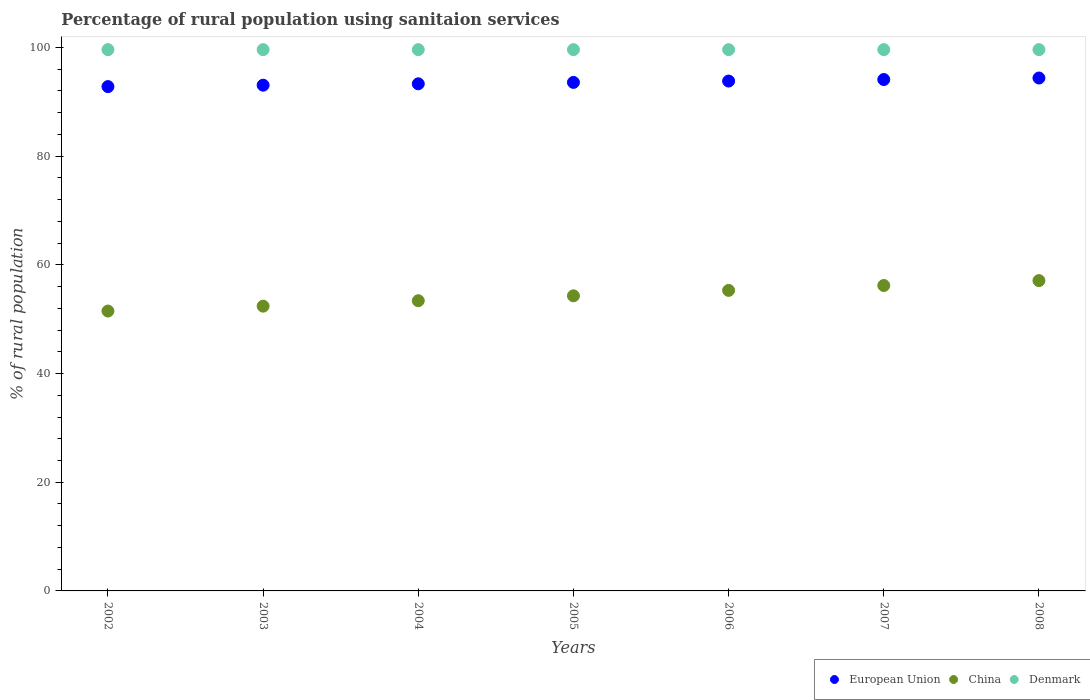How many different coloured dotlines are there?
Give a very brief answer. 3. What is the percentage of rural population using sanitaion services in European Union in 2006?
Your answer should be compact. 93.82. Across all years, what is the maximum percentage of rural population using sanitaion services in Denmark?
Ensure brevity in your answer.  99.6. Across all years, what is the minimum percentage of rural population using sanitaion services in Denmark?
Keep it short and to the point. 99.6. In which year was the percentage of rural population using sanitaion services in China minimum?
Your answer should be compact. 2002. What is the total percentage of rural population using sanitaion services in European Union in the graph?
Offer a terse response. 655.05. What is the difference between the percentage of rural population using sanitaion services in China in 2003 and that in 2008?
Provide a succinct answer. -4.7. What is the difference between the percentage of rural population using sanitaion services in European Union in 2002 and the percentage of rural population using sanitaion services in Denmark in 2005?
Your response must be concise. -6.8. What is the average percentage of rural population using sanitaion services in European Union per year?
Your answer should be compact. 93.58. In the year 2004, what is the difference between the percentage of rural population using sanitaion services in China and percentage of rural population using sanitaion services in Denmark?
Your response must be concise. -46.2. Is the difference between the percentage of rural population using sanitaion services in China in 2005 and 2006 greater than the difference between the percentage of rural population using sanitaion services in Denmark in 2005 and 2006?
Offer a terse response. No. What is the difference between the highest and the second highest percentage of rural population using sanitaion services in China?
Ensure brevity in your answer.  0.9. What is the difference between the highest and the lowest percentage of rural population using sanitaion services in European Union?
Your answer should be very brief. 1.58. In how many years, is the percentage of rural population using sanitaion services in Denmark greater than the average percentage of rural population using sanitaion services in Denmark taken over all years?
Your answer should be very brief. 0. Is the percentage of rural population using sanitaion services in European Union strictly less than the percentage of rural population using sanitaion services in China over the years?
Keep it short and to the point. No. How many dotlines are there?
Provide a succinct answer. 3. How many years are there in the graph?
Ensure brevity in your answer.  7. What is the difference between two consecutive major ticks on the Y-axis?
Give a very brief answer. 20. Are the values on the major ticks of Y-axis written in scientific E-notation?
Offer a terse response. No. Does the graph contain any zero values?
Offer a very short reply. No. What is the title of the graph?
Provide a succinct answer. Percentage of rural population using sanitaion services. What is the label or title of the X-axis?
Provide a short and direct response. Years. What is the label or title of the Y-axis?
Your answer should be very brief. % of rural population. What is the % of rural population in European Union in 2002?
Your response must be concise. 92.8. What is the % of rural population in China in 2002?
Offer a very short reply. 51.5. What is the % of rural population of Denmark in 2002?
Your answer should be compact. 99.6. What is the % of rural population in European Union in 2003?
Your answer should be compact. 93.06. What is the % of rural population of China in 2003?
Give a very brief answer. 52.4. What is the % of rural population of Denmark in 2003?
Ensure brevity in your answer.  99.6. What is the % of rural population in European Union in 2004?
Offer a very short reply. 93.31. What is the % of rural population of China in 2004?
Your answer should be compact. 53.4. What is the % of rural population of Denmark in 2004?
Keep it short and to the point. 99.6. What is the % of rural population in European Union in 2005?
Keep it short and to the point. 93.57. What is the % of rural population in China in 2005?
Offer a terse response. 54.3. What is the % of rural population in Denmark in 2005?
Ensure brevity in your answer.  99.6. What is the % of rural population in European Union in 2006?
Give a very brief answer. 93.82. What is the % of rural population of China in 2006?
Make the answer very short. 55.3. What is the % of rural population of Denmark in 2006?
Ensure brevity in your answer.  99.6. What is the % of rural population in European Union in 2007?
Make the answer very short. 94.1. What is the % of rural population of China in 2007?
Your response must be concise. 56.2. What is the % of rural population of Denmark in 2007?
Make the answer very short. 99.6. What is the % of rural population of European Union in 2008?
Ensure brevity in your answer.  94.38. What is the % of rural population in China in 2008?
Keep it short and to the point. 57.1. What is the % of rural population of Denmark in 2008?
Offer a very short reply. 99.6. Across all years, what is the maximum % of rural population in European Union?
Provide a succinct answer. 94.38. Across all years, what is the maximum % of rural population of China?
Your response must be concise. 57.1. Across all years, what is the maximum % of rural population of Denmark?
Offer a very short reply. 99.6. Across all years, what is the minimum % of rural population of European Union?
Make the answer very short. 92.8. Across all years, what is the minimum % of rural population in China?
Offer a very short reply. 51.5. Across all years, what is the minimum % of rural population of Denmark?
Give a very brief answer. 99.6. What is the total % of rural population of European Union in the graph?
Provide a succinct answer. 655.05. What is the total % of rural population in China in the graph?
Provide a short and direct response. 380.2. What is the total % of rural population in Denmark in the graph?
Your answer should be compact. 697.2. What is the difference between the % of rural population of European Union in 2002 and that in 2003?
Keep it short and to the point. -0.26. What is the difference between the % of rural population in Denmark in 2002 and that in 2003?
Provide a short and direct response. 0. What is the difference between the % of rural population in European Union in 2002 and that in 2004?
Provide a short and direct response. -0.51. What is the difference between the % of rural population of China in 2002 and that in 2004?
Offer a very short reply. -1.9. What is the difference between the % of rural population of European Union in 2002 and that in 2005?
Your answer should be very brief. -0.77. What is the difference between the % of rural population of China in 2002 and that in 2005?
Make the answer very short. -2.8. What is the difference between the % of rural population of European Union in 2002 and that in 2006?
Provide a short and direct response. -1.02. What is the difference between the % of rural population of European Union in 2002 and that in 2007?
Your response must be concise. -1.3. What is the difference between the % of rural population in China in 2002 and that in 2007?
Ensure brevity in your answer.  -4.7. What is the difference between the % of rural population in Denmark in 2002 and that in 2007?
Keep it short and to the point. 0. What is the difference between the % of rural population in European Union in 2002 and that in 2008?
Your answer should be very brief. -1.58. What is the difference between the % of rural population in China in 2002 and that in 2008?
Offer a terse response. -5.6. What is the difference between the % of rural population of European Union in 2003 and that in 2004?
Your answer should be very brief. -0.25. What is the difference between the % of rural population in China in 2003 and that in 2004?
Give a very brief answer. -1. What is the difference between the % of rural population of Denmark in 2003 and that in 2004?
Provide a short and direct response. 0. What is the difference between the % of rural population in European Union in 2003 and that in 2005?
Give a very brief answer. -0.51. What is the difference between the % of rural population in Denmark in 2003 and that in 2005?
Provide a succinct answer. 0. What is the difference between the % of rural population in European Union in 2003 and that in 2006?
Make the answer very short. -0.76. What is the difference between the % of rural population of China in 2003 and that in 2006?
Your answer should be compact. -2.9. What is the difference between the % of rural population of Denmark in 2003 and that in 2006?
Your answer should be compact. 0. What is the difference between the % of rural population in European Union in 2003 and that in 2007?
Offer a very short reply. -1.04. What is the difference between the % of rural population of China in 2003 and that in 2007?
Give a very brief answer. -3.8. What is the difference between the % of rural population of European Union in 2003 and that in 2008?
Your response must be concise. -1.32. What is the difference between the % of rural population of European Union in 2004 and that in 2005?
Make the answer very short. -0.26. What is the difference between the % of rural population of China in 2004 and that in 2005?
Keep it short and to the point. -0.9. What is the difference between the % of rural population in European Union in 2004 and that in 2006?
Make the answer very short. -0.51. What is the difference between the % of rural population in European Union in 2004 and that in 2007?
Provide a short and direct response. -0.79. What is the difference between the % of rural population of China in 2004 and that in 2007?
Offer a very short reply. -2.8. What is the difference between the % of rural population of European Union in 2004 and that in 2008?
Make the answer very short. -1.07. What is the difference between the % of rural population of European Union in 2005 and that in 2006?
Your response must be concise. -0.25. What is the difference between the % of rural population of China in 2005 and that in 2006?
Offer a very short reply. -1. What is the difference between the % of rural population of European Union in 2005 and that in 2007?
Make the answer very short. -0.53. What is the difference between the % of rural population of China in 2005 and that in 2007?
Keep it short and to the point. -1.9. What is the difference between the % of rural population in European Union in 2005 and that in 2008?
Offer a very short reply. -0.81. What is the difference between the % of rural population of China in 2005 and that in 2008?
Provide a short and direct response. -2.8. What is the difference between the % of rural population of Denmark in 2005 and that in 2008?
Your response must be concise. 0. What is the difference between the % of rural population in European Union in 2006 and that in 2007?
Make the answer very short. -0.28. What is the difference between the % of rural population in China in 2006 and that in 2007?
Provide a succinct answer. -0.9. What is the difference between the % of rural population of European Union in 2006 and that in 2008?
Offer a very short reply. -0.56. What is the difference between the % of rural population of European Union in 2007 and that in 2008?
Give a very brief answer. -0.28. What is the difference between the % of rural population of China in 2007 and that in 2008?
Your answer should be very brief. -0.9. What is the difference between the % of rural population in Denmark in 2007 and that in 2008?
Your answer should be very brief. 0. What is the difference between the % of rural population of European Union in 2002 and the % of rural population of China in 2003?
Make the answer very short. 40.4. What is the difference between the % of rural population of European Union in 2002 and the % of rural population of Denmark in 2003?
Offer a terse response. -6.8. What is the difference between the % of rural population of China in 2002 and the % of rural population of Denmark in 2003?
Keep it short and to the point. -48.1. What is the difference between the % of rural population in European Union in 2002 and the % of rural population in China in 2004?
Keep it short and to the point. 39.4. What is the difference between the % of rural population of European Union in 2002 and the % of rural population of Denmark in 2004?
Make the answer very short. -6.8. What is the difference between the % of rural population in China in 2002 and the % of rural population in Denmark in 2004?
Provide a short and direct response. -48.1. What is the difference between the % of rural population in European Union in 2002 and the % of rural population in China in 2005?
Give a very brief answer. 38.5. What is the difference between the % of rural population of European Union in 2002 and the % of rural population of Denmark in 2005?
Give a very brief answer. -6.8. What is the difference between the % of rural population of China in 2002 and the % of rural population of Denmark in 2005?
Your answer should be compact. -48.1. What is the difference between the % of rural population in European Union in 2002 and the % of rural population in China in 2006?
Your answer should be compact. 37.5. What is the difference between the % of rural population of European Union in 2002 and the % of rural population of Denmark in 2006?
Offer a very short reply. -6.8. What is the difference between the % of rural population of China in 2002 and the % of rural population of Denmark in 2006?
Your response must be concise. -48.1. What is the difference between the % of rural population of European Union in 2002 and the % of rural population of China in 2007?
Offer a terse response. 36.6. What is the difference between the % of rural population in European Union in 2002 and the % of rural population in Denmark in 2007?
Your response must be concise. -6.8. What is the difference between the % of rural population of China in 2002 and the % of rural population of Denmark in 2007?
Make the answer very short. -48.1. What is the difference between the % of rural population in European Union in 2002 and the % of rural population in China in 2008?
Give a very brief answer. 35.7. What is the difference between the % of rural population in European Union in 2002 and the % of rural population in Denmark in 2008?
Make the answer very short. -6.8. What is the difference between the % of rural population of China in 2002 and the % of rural population of Denmark in 2008?
Ensure brevity in your answer.  -48.1. What is the difference between the % of rural population of European Union in 2003 and the % of rural population of China in 2004?
Ensure brevity in your answer.  39.66. What is the difference between the % of rural population in European Union in 2003 and the % of rural population in Denmark in 2004?
Your response must be concise. -6.54. What is the difference between the % of rural population in China in 2003 and the % of rural population in Denmark in 2004?
Keep it short and to the point. -47.2. What is the difference between the % of rural population of European Union in 2003 and the % of rural population of China in 2005?
Ensure brevity in your answer.  38.76. What is the difference between the % of rural population in European Union in 2003 and the % of rural population in Denmark in 2005?
Ensure brevity in your answer.  -6.54. What is the difference between the % of rural population in China in 2003 and the % of rural population in Denmark in 2005?
Your answer should be compact. -47.2. What is the difference between the % of rural population in European Union in 2003 and the % of rural population in China in 2006?
Provide a short and direct response. 37.76. What is the difference between the % of rural population of European Union in 2003 and the % of rural population of Denmark in 2006?
Give a very brief answer. -6.54. What is the difference between the % of rural population in China in 2003 and the % of rural population in Denmark in 2006?
Offer a very short reply. -47.2. What is the difference between the % of rural population in European Union in 2003 and the % of rural population in China in 2007?
Make the answer very short. 36.86. What is the difference between the % of rural population in European Union in 2003 and the % of rural population in Denmark in 2007?
Your answer should be very brief. -6.54. What is the difference between the % of rural population of China in 2003 and the % of rural population of Denmark in 2007?
Ensure brevity in your answer.  -47.2. What is the difference between the % of rural population of European Union in 2003 and the % of rural population of China in 2008?
Provide a short and direct response. 35.96. What is the difference between the % of rural population of European Union in 2003 and the % of rural population of Denmark in 2008?
Provide a short and direct response. -6.54. What is the difference between the % of rural population of China in 2003 and the % of rural population of Denmark in 2008?
Keep it short and to the point. -47.2. What is the difference between the % of rural population in European Union in 2004 and the % of rural population in China in 2005?
Provide a succinct answer. 39.01. What is the difference between the % of rural population in European Union in 2004 and the % of rural population in Denmark in 2005?
Your response must be concise. -6.29. What is the difference between the % of rural population in China in 2004 and the % of rural population in Denmark in 2005?
Make the answer very short. -46.2. What is the difference between the % of rural population in European Union in 2004 and the % of rural population in China in 2006?
Your answer should be compact. 38.01. What is the difference between the % of rural population of European Union in 2004 and the % of rural population of Denmark in 2006?
Your answer should be very brief. -6.29. What is the difference between the % of rural population of China in 2004 and the % of rural population of Denmark in 2006?
Offer a very short reply. -46.2. What is the difference between the % of rural population of European Union in 2004 and the % of rural population of China in 2007?
Keep it short and to the point. 37.11. What is the difference between the % of rural population in European Union in 2004 and the % of rural population in Denmark in 2007?
Offer a very short reply. -6.29. What is the difference between the % of rural population in China in 2004 and the % of rural population in Denmark in 2007?
Your answer should be compact. -46.2. What is the difference between the % of rural population in European Union in 2004 and the % of rural population in China in 2008?
Offer a terse response. 36.21. What is the difference between the % of rural population of European Union in 2004 and the % of rural population of Denmark in 2008?
Ensure brevity in your answer.  -6.29. What is the difference between the % of rural population in China in 2004 and the % of rural population in Denmark in 2008?
Your answer should be very brief. -46.2. What is the difference between the % of rural population of European Union in 2005 and the % of rural population of China in 2006?
Keep it short and to the point. 38.27. What is the difference between the % of rural population in European Union in 2005 and the % of rural population in Denmark in 2006?
Provide a short and direct response. -6.03. What is the difference between the % of rural population in China in 2005 and the % of rural population in Denmark in 2006?
Your answer should be compact. -45.3. What is the difference between the % of rural population in European Union in 2005 and the % of rural population in China in 2007?
Ensure brevity in your answer.  37.37. What is the difference between the % of rural population in European Union in 2005 and the % of rural population in Denmark in 2007?
Make the answer very short. -6.03. What is the difference between the % of rural population in China in 2005 and the % of rural population in Denmark in 2007?
Ensure brevity in your answer.  -45.3. What is the difference between the % of rural population of European Union in 2005 and the % of rural population of China in 2008?
Provide a short and direct response. 36.47. What is the difference between the % of rural population of European Union in 2005 and the % of rural population of Denmark in 2008?
Keep it short and to the point. -6.03. What is the difference between the % of rural population of China in 2005 and the % of rural population of Denmark in 2008?
Provide a succinct answer. -45.3. What is the difference between the % of rural population in European Union in 2006 and the % of rural population in China in 2007?
Provide a succinct answer. 37.62. What is the difference between the % of rural population of European Union in 2006 and the % of rural population of Denmark in 2007?
Your answer should be compact. -5.78. What is the difference between the % of rural population in China in 2006 and the % of rural population in Denmark in 2007?
Provide a short and direct response. -44.3. What is the difference between the % of rural population of European Union in 2006 and the % of rural population of China in 2008?
Your answer should be very brief. 36.72. What is the difference between the % of rural population in European Union in 2006 and the % of rural population in Denmark in 2008?
Give a very brief answer. -5.78. What is the difference between the % of rural population in China in 2006 and the % of rural population in Denmark in 2008?
Make the answer very short. -44.3. What is the difference between the % of rural population of European Union in 2007 and the % of rural population of China in 2008?
Provide a succinct answer. 37. What is the difference between the % of rural population in European Union in 2007 and the % of rural population in Denmark in 2008?
Keep it short and to the point. -5.5. What is the difference between the % of rural population of China in 2007 and the % of rural population of Denmark in 2008?
Provide a short and direct response. -43.4. What is the average % of rural population of European Union per year?
Give a very brief answer. 93.58. What is the average % of rural population in China per year?
Keep it short and to the point. 54.31. What is the average % of rural population in Denmark per year?
Offer a very short reply. 99.6. In the year 2002, what is the difference between the % of rural population in European Union and % of rural population in China?
Ensure brevity in your answer.  41.3. In the year 2002, what is the difference between the % of rural population in European Union and % of rural population in Denmark?
Provide a succinct answer. -6.8. In the year 2002, what is the difference between the % of rural population of China and % of rural population of Denmark?
Your answer should be compact. -48.1. In the year 2003, what is the difference between the % of rural population of European Union and % of rural population of China?
Ensure brevity in your answer.  40.66. In the year 2003, what is the difference between the % of rural population in European Union and % of rural population in Denmark?
Keep it short and to the point. -6.54. In the year 2003, what is the difference between the % of rural population in China and % of rural population in Denmark?
Your answer should be very brief. -47.2. In the year 2004, what is the difference between the % of rural population in European Union and % of rural population in China?
Keep it short and to the point. 39.91. In the year 2004, what is the difference between the % of rural population in European Union and % of rural population in Denmark?
Offer a very short reply. -6.29. In the year 2004, what is the difference between the % of rural population of China and % of rural population of Denmark?
Ensure brevity in your answer.  -46.2. In the year 2005, what is the difference between the % of rural population in European Union and % of rural population in China?
Your answer should be very brief. 39.27. In the year 2005, what is the difference between the % of rural population in European Union and % of rural population in Denmark?
Your answer should be compact. -6.03. In the year 2005, what is the difference between the % of rural population of China and % of rural population of Denmark?
Give a very brief answer. -45.3. In the year 2006, what is the difference between the % of rural population of European Union and % of rural population of China?
Give a very brief answer. 38.52. In the year 2006, what is the difference between the % of rural population of European Union and % of rural population of Denmark?
Your response must be concise. -5.78. In the year 2006, what is the difference between the % of rural population in China and % of rural population in Denmark?
Make the answer very short. -44.3. In the year 2007, what is the difference between the % of rural population of European Union and % of rural population of China?
Offer a terse response. 37.9. In the year 2007, what is the difference between the % of rural population in European Union and % of rural population in Denmark?
Your answer should be very brief. -5.5. In the year 2007, what is the difference between the % of rural population of China and % of rural population of Denmark?
Keep it short and to the point. -43.4. In the year 2008, what is the difference between the % of rural population of European Union and % of rural population of China?
Give a very brief answer. 37.28. In the year 2008, what is the difference between the % of rural population of European Union and % of rural population of Denmark?
Provide a short and direct response. -5.22. In the year 2008, what is the difference between the % of rural population in China and % of rural population in Denmark?
Offer a terse response. -42.5. What is the ratio of the % of rural population in China in 2002 to that in 2003?
Provide a short and direct response. 0.98. What is the ratio of the % of rural population of Denmark in 2002 to that in 2003?
Your answer should be compact. 1. What is the ratio of the % of rural population of European Union in 2002 to that in 2004?
Give a very brief answer. 0.99. What is the ratio of the % of rural population in China in 2002 to that in 2004?
Offer a terse response. 0.96. What is the ratio of the % of rural population in Denmark in 2002 to that in 2004?
Offer a terse response. 1. What is the ratio of the % of rural population in China in 2002 to that in 2005?
Your answer should be compact. 0.95. What is the ratio of the % of rural population of European Union in 2002 to that in 2006?
Provide a short and direct response. 0.99. What is the ratio of the % of rural population in China in 2002 to that in 2006?
Offer a very short reply. 0.93. What is the ratio of the % of rural population of European Union in 2002 to that in 2007?
Provide a succinct answer. 0.99. What is the ratio of the % of rural population in China in 2002 to that in 2007?
Make the answer very short. 0.92. What is the ratio of the % of rural population in European Union in 2002 to that in 2008?
Your answer should be compact. 0.98. What is the ratio of the % of rural population in China in 2002 to that in 2008?
Offer a very short reply. 0.9. What is the ratio of the % of rural population of Denmark in 2002 to that in 2008?
Keep it short and to the point. 1. What is the ratio of the % of rural population of European Union in 2003 to that in 2004?
Keep it short and to the point. 1. What is the ratio of the % of rural population of China in 2003 to that in 2004?
Offer a very short reply. 0.98. What is the ratio of the % of rural population of Denmark in 2003 to that in 2004?
Give a very brief answer. 1. What is the ratio of the % of rural population in China in 2003 to that in 2006?
Offer a terse response. 0.95. What is the ratio of the % of rural population in European Union in 2003 to that in 2007?
Offer a very short reply. 0.99. What is the ratio of the % of rural population in China in 2003 to that in 2007?
Offer a terse response. 0.93. What is the ratio of the % of rural population in China in 2003 to that in 2008?
Give a very brief answer. 0.92. What is the ratio of the % of rural population of Denmark in 2003 to that in 2008?
Make the answer very short. 1. What is the ratio of the % of rural population in China in 2004 to that in 2005?
Give a very brief answer. 0.98. What is the ratio of the % of rural population of Denmark in 2004 to that in 2005?
Your answer should be compact. 1. What is the ratio of the % of rural population in China in 2004 to that in 2006?
Your response must be concise. 0.97. What is the ratio of the % of rural population in European Union in 2004 to that in 2007?
Your response must be concise. 0.99. What is the ratio of the % of rural population in China in 2004 to that in 2007?
Make the answer very short. 0.95. What is the ratio of the % of rural population of European Union in 2004 to that in 2008?
Offer a very short reply. 0.99. What is the ratio of the % of rural population of China in 2004 to that in 2008?
Your answer should be very brief. 0.94. What is the ratio of the % of rural population in Denmark in 2004 to that in 2008?
Offer a terse response. 1. What is the ratio of the % of rural population in China in 2005 to that in 2006?
Provide a short and direct response. 0.98. What is the ratio of the % of rural population of Denmark in 2005 to that in 2006?
Offer a terse response. 1. What is the ratio of the % of rural population in China in 2005 to that in 2007?
Provide a succinct answer. 0.97. What is the ratio of the % of rural population in Denmark in 2005 to that in 2007?
Give a very brief answer. 1. What is the ratio of the % of rural population of China in 2005 to that in 2008?
Give a very brief answer. 0.95. What is the ratio of the % of rural population in European Union in 2006 to that in 2007?
Your answer should be compact. 1. What is the ratio of the % of rural population in European Union in 2006 to that in 2008?
Make the answer very short. 0.99. What is the ratio of the % of rural population in China in 2006 to that in 2008?
Ensure brevity in your answer.  0.97. What is the ratio of the % of rural population in Denmark in 2006 to that in 2008?
Make the answer very short. 1. What is the ratio of the % of rural population of China in 2007 to that in 2008?
Keep it short and to the point. 0.98. What is the ratio of the % of rural population in Denmark in 2007 to that in 2008?
Keep it short and to the point. 1. What is the difference between the highest and the second highest % of rural population of European Union?
Make the answer very short. 0.28. What is the difference between the highest and the second highest % of rural population of China?
Make the answer very short. 0.9. What is the difference between the highest and the second highest % of rural population of Denmark?
Give a very brief answer. 0. What is the difference between the highest and the lowest % of rural population of European Union?
Offer a terse response. 1.58. What is the difference between the highest and the lowest % of rural population in Denmark?
Your response must be concise. 0. 